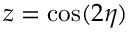<formula> <loc_0><loc_0><loc_500><loc_500>z = \cos ( 2 \eta )</formula> 